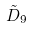<formula> <loc_0><loc_0><loc_500><loc_500>\tilde { D } _ { 9 }</formula> 